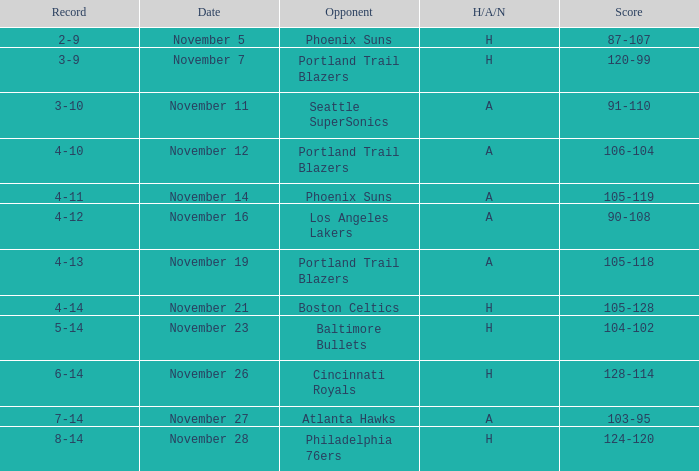What is the Opponent of the game with a H/A/N of H and Score of 120-99? Portland Trail Blazers. I'm looking to parse the entire table for insights. Could you assist me with that? {'header': ['Record', 'Date', 'Opponent', 'H/A/N', 'Score'], 'rows': [['2-9', 'November 5', 'Phoenix Suns', 'H', '87-107'], ['3-9', 'November 7', 'Portland Trail Blazers', 'H', '120-99'], ['3-10', 'November 11', 'Seattle SuperSonics', 'A', '91-110'], ['4-10', 'November 12', 'Portland Trail Blazers', 'A', '106-104'], ['4-11', 'November 14', 'Phoenix Suns', 'A', '105-119'], ['4-12', 'November 16', 'Los Angeles Lakers', 'A', '90-108'], ['4-13', 'November 19', 'Portland Trail Blazers', 'A', '105-118'], ['4-14', 'November 21', 'Boston Celtics', 'H', '105-128'], ['5-14', 'November 23', 'Baltimore Bullets', 'H', '104-102'], ['6-14', 'November 26', 'Cincinnati Royals', 'H', '128-114'], ['7-14', 'November 27', 'Atlanta Hawks', 'A', '103-95'], ['8-14', 'November 28', 'Philadelphia 76ers', 'H', '124-120']]} 